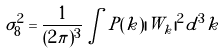Convert formula to latex. <formula><loc_0><loc_0><loc_500><loc_500>\sigma _ { 8 } ^ { 2 } = \frac { 1 } { ( 2 \pi ) ^ { 3 } } \int P ( k ) | W _ { k } | ^ { 2 } d ^ { 3 } k \,</formula> 